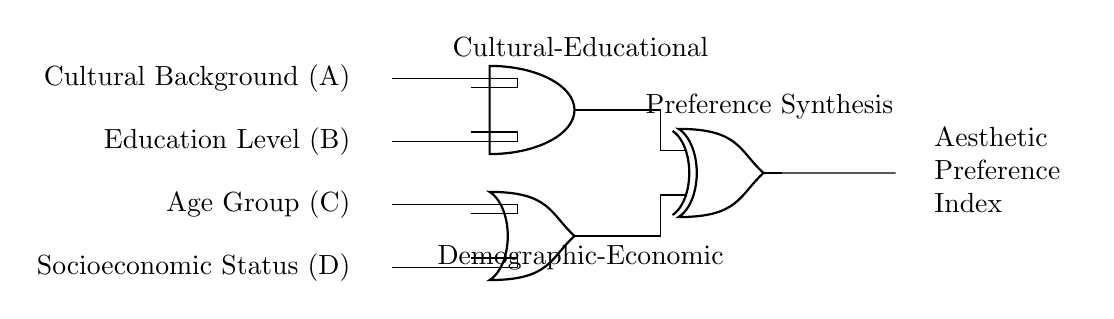What are the inputs to the circuit? The inputs to the circuit are cultural background, education level, age group, and socioeconomic status. Each of these represents a distinct factor influencing aesthetic preferences and is connected to the corresponding input node.
Answer: cultural background, education level, age group, socioeconomic status What is the output of the circuit? The output of the circuit is the Aesthetic Preference Index, which synthesizes the outputs from the logic gates based on the inputs provided. This index is intended to represent a combined measure of aesthetic preferences influenced by the demographic and educational factors.
Answer: Aesthetic Preference Index What type of logic gate is used to combine cultural background and education level? The type of logic gate that combines cultural background and education level is an AND gate, which requires both inputs to be true (or 'on') to produce a true output.
Answer: AND What is the function of the XOR gate in this circuit? The XOR gate in this circuit takes inputs from the previous layer (the outputs of the AND and OR gates) and produces an output that is true only if one of the inputs is true but not both. This allows it to capture a specific dynamic in aesthetic preference synthesis, potentially differentiating unique combinations of the inputs.
Answer: Unique preference synthesis How does the OR gate function with its inputs? The OR gate in this circuit receives inputs from the age group and socioeconomic status and outputs true if at least one of its inputs is true. This gate is designed to reflect that any influence from either demographic factor can contribute positively to the preference index.
Answer: Any influence from inputs What is the connection between the AND gate and the XOR gate? The AND gate's output connects to one input of the XOR gate while the OR gate's output connects to the other. This shows that the result of combining cultural background and education level feeds into the XOR gate, which then synthesizes this information with the combined output from the demographic factors.
Answer: AND feeds into XOR 